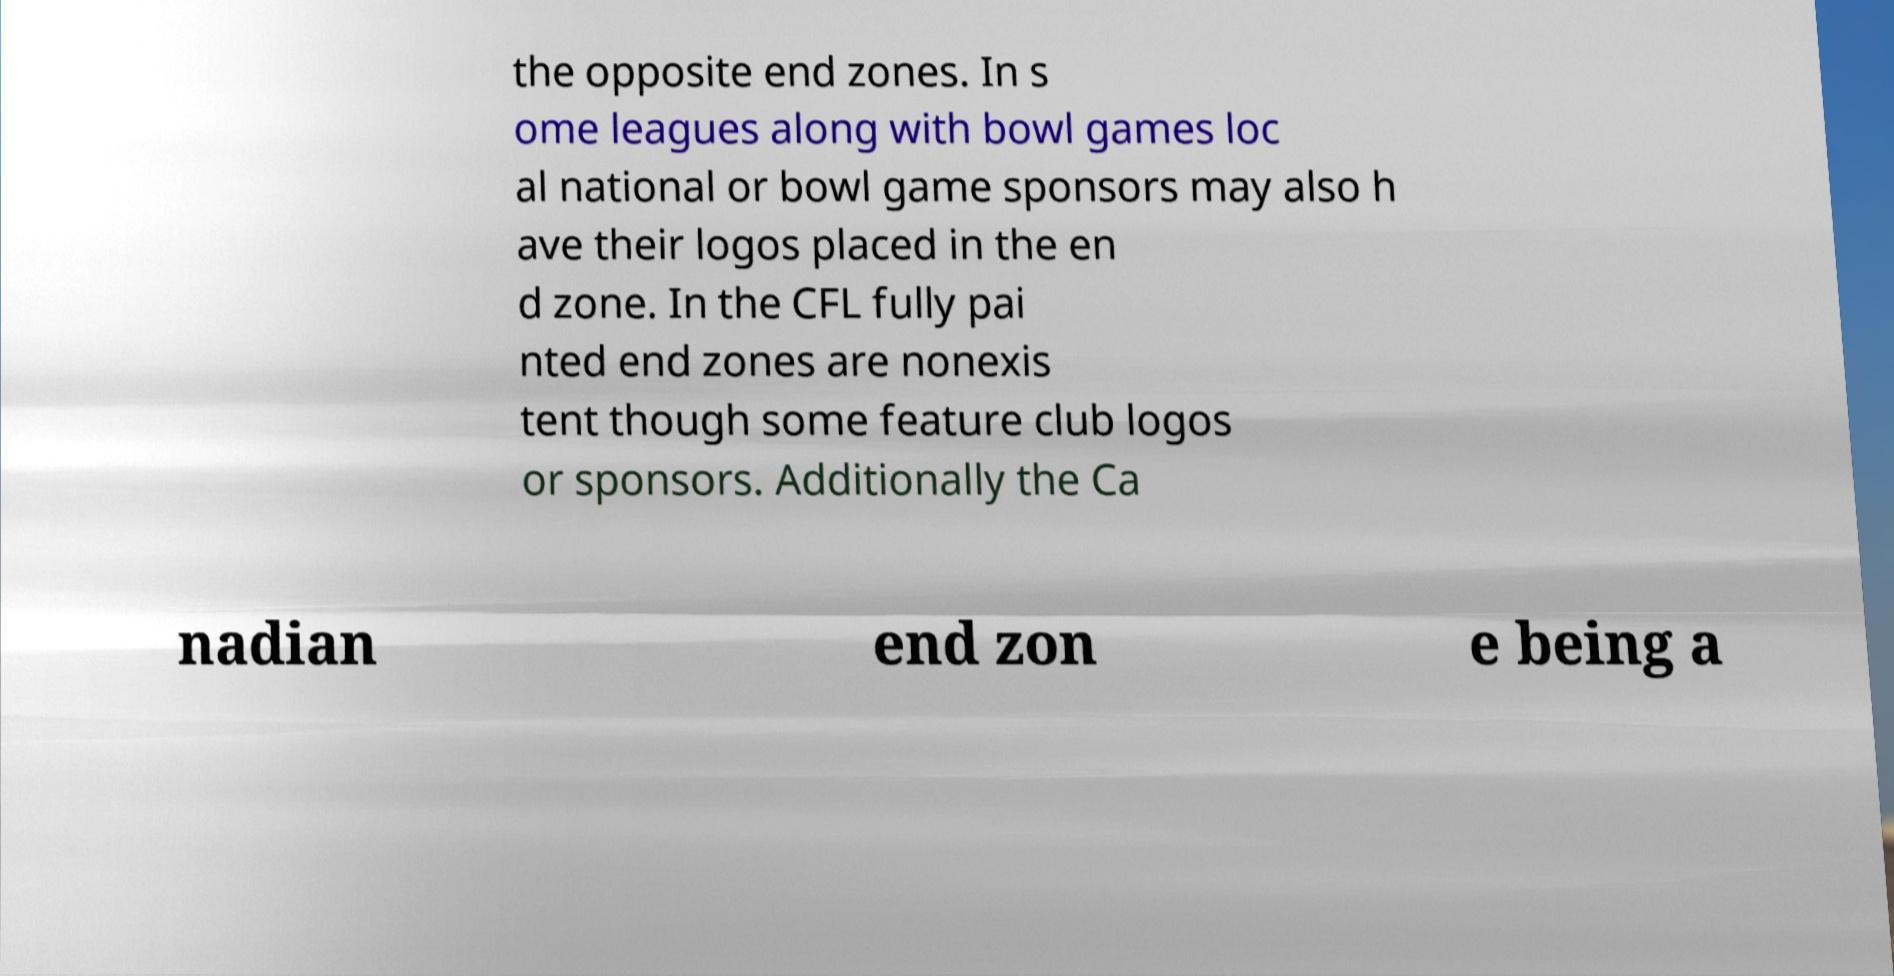There's text embedded in this image that I need extracted. Can you transcribe it verbatim? the opposite end zones. In s ome leagues along with bowl games loc al national or bowl game sponsors may also h ave their logos placed in the en d zone. In the CFL fully pai nted end zones are nonexis tent though some feature club logos or sponsors. Additionally the Ca nadian end zon e being a 